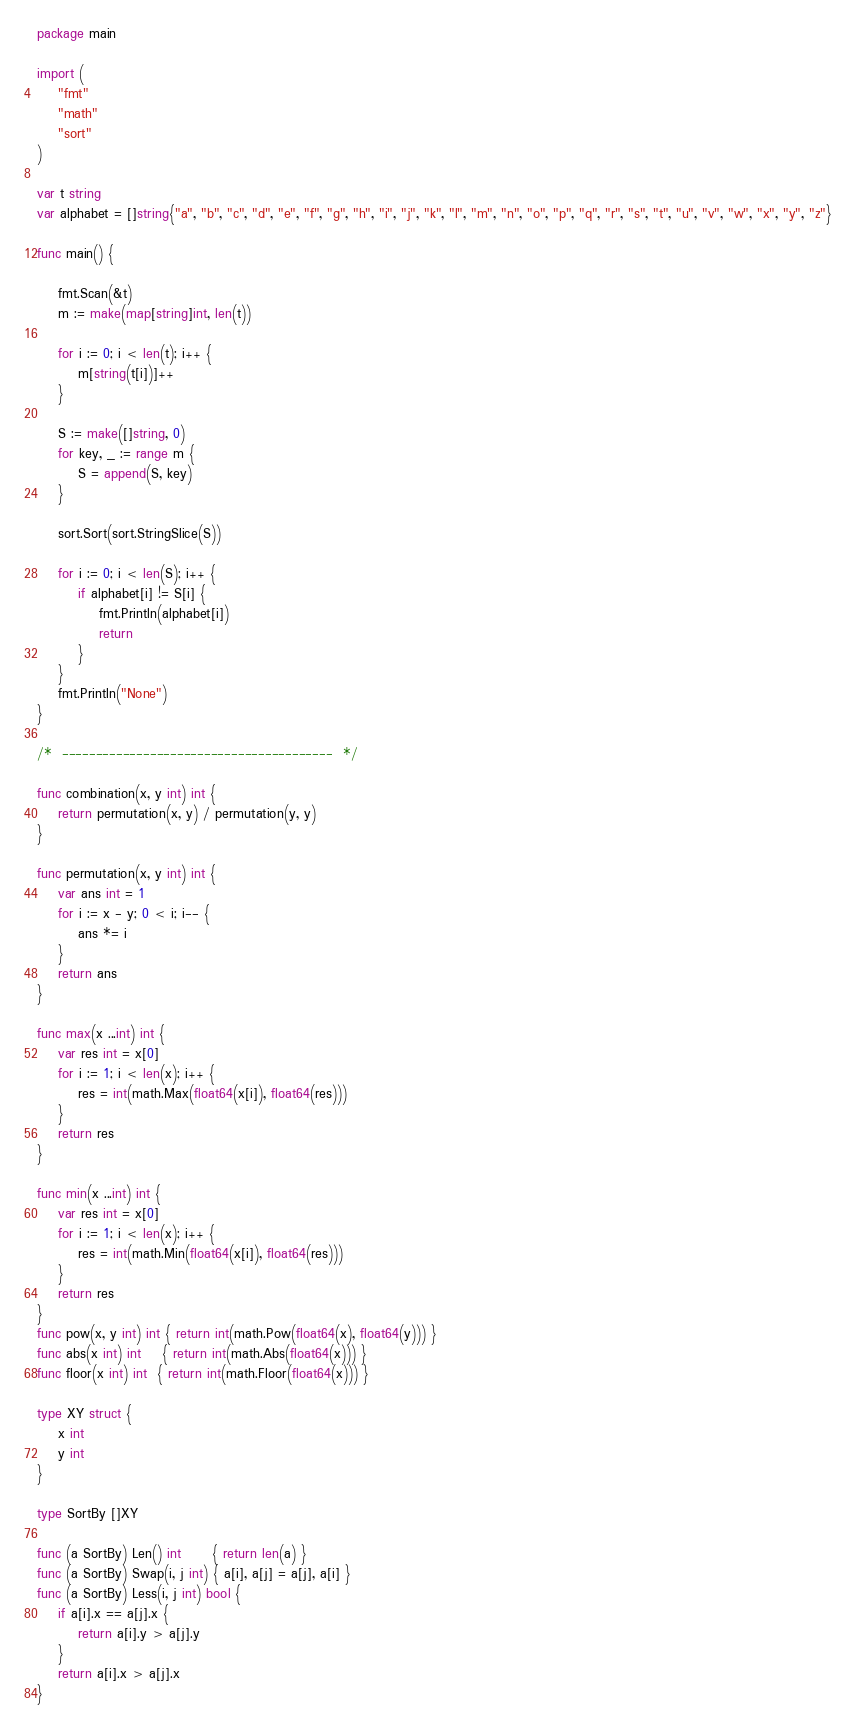<code> <loc_0><loc_0><loc_500><loc_500><_Go_>package main

import (
	"fmt"
	"math"
	"sort"
)

var t string
var alphabet = []string{"a", "b", "c", "d", "e", "f", "g", "h", "i", "j", "k", "l", "m", "n", "o", "p", "q", "r", "s", "t", "u", "v", "w", "x", "y", "z"}

func main() {

	fmt.Scan(&t)
	m := make(map[string]int, len(t))

	for i := 0; i < len(t); i++ {
		m[string(t[i])]++
	}

	S := make([]string, 0)
	for key, _ := range m {
		S = append(S, key)
	}

	sort.Sort(sort.StringSlice(S))

	for i := 0; i < len(S); i++ {
		if alphabet[i] != S[i] {
			fmt.Println(alphabet[i])
			return
		}
	}
	fmt.Println("None")
}

/*  ----------------------------------------  */

func combination(x, y int) int {
	return permutation(x, y) / permutation(y, y)
}

func permutation(x, y int) int {
	var ans int = 1
	for i := x - y; 0 < i; i-- {
		ans *= i
	}
	return ans
}

func max(x ...int) int {
	var res int = x[0]
	for i := 1; i < len(x); i++ {
		res = int(math.Max(float64(x[i]), float64(res)))
	}
	return res
}

func min(x ...int) int {
	var res int = x[0]
	for i := 1; i < len(x); i++ {
		res = int(math.Min(float64(x[i]), float64(res)))
	}
	return res
}
func pow(x, y int) int { return int(math.Pow(float64(x), float64(y))) }
func abs(x int) int    { return int(math.Abs(float64(x))) }
func floor(x int) int  { return int(math.Floor(float64(x))) }

type XY struct {
	x int
	y int
}

type SortBy []XY

func (a SortBy) Len() int      { return len(a) }
func (a SortBy) Swap(i, j int) { a[i], a[j] = a[j], a[i] }
func (a SortBy) Less(i, j int) bool {
	if a[i].x == a[j].x {
		return a[i].y > a[j].y
	}
	return a[i].x > a[j].x
}
</code> 